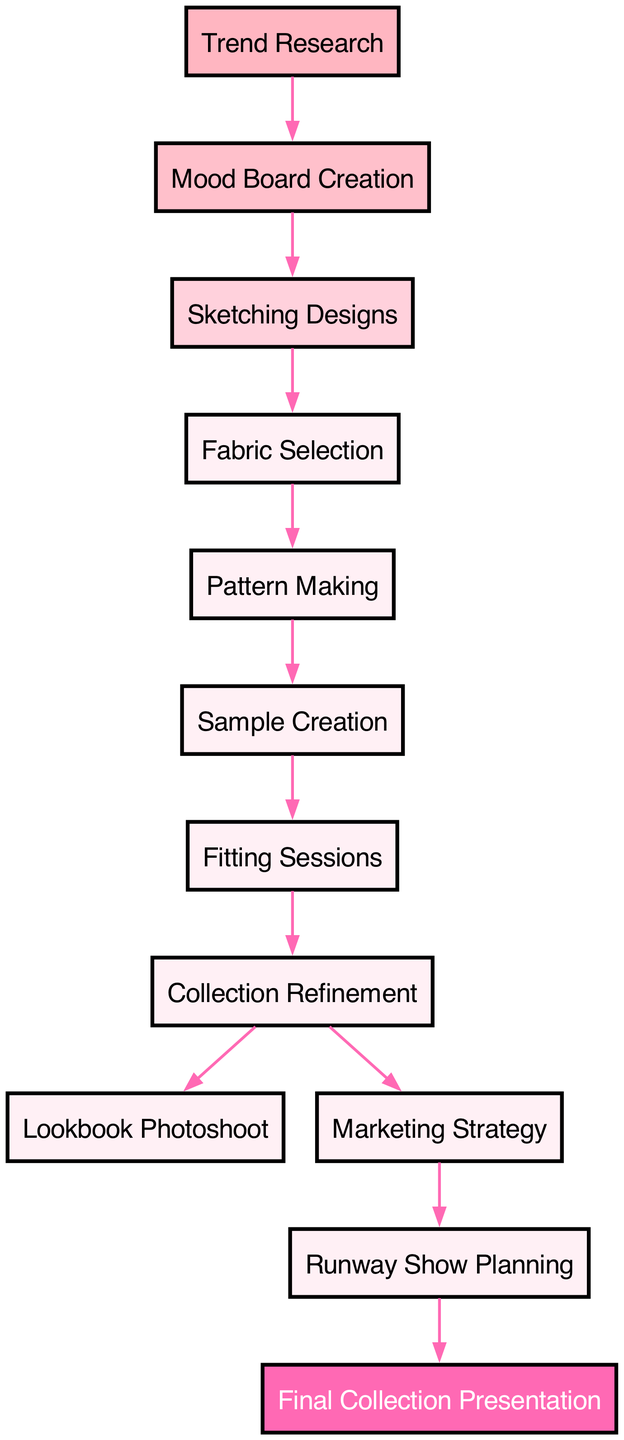What is the first step in the fashion collection development process? The diagram shows "Trend Research" as the starting point, which is the first node connected to the flow of the process.
Answer: Trend Research How many steps are there in total for the collection development process? The diagram lists 12 distinct nodes, indicating that there are 12 key steps involved in the process.
Answer: 12 What is the relationship between "Fabric Selection" and "Pattern Making"? The diagram illustrates a direct connection from "Fabric Selection" to "Pattern Making," indicating that pattern making follows after the selection of fabric.
Answer: Fabric Selection leads to Pattern Making After "Fitting Sessions," what is the next step in the process? From the flow of the diagram, "Fitting Sessions" leads directly into "Collection Refinement," showing that refinement is the subsequent step.
Answer: Collection Refinement Which node has the final collection presentation? The last node in the flow, "Final Collection Presentation," signifies that this is the concluding step of the process.
Answer: Final Collection Presentation What are the two branches that emanate from "Collection Refinement"? The diagram shows two edges leading out of "Collection Refinement": one going to "Lookbook Photoshoot" and the other to "Marketing Strategy," which illustrates the options that follow refinement.
Answer: Lookbook Photoshoot and Marketing Strategy How many edges are present in the diagram? By counting the connections (edges) between nodes in the diagram, there are a total of 11 edges that represent the flow between the various steps.
Answer: 11 What is the color of the "Final Collection Presentation" node? Referring to the styling in the diagram, "Final Collection Presentation" is uniquely colored with a pink shade, represented as '#FF69B4' in the styles.
Answer: Pink What is the node before "Lookbook Photoshoot"? The diagram clearly indicates a direct connection from "Collection Refinement" to "Lookbook Photoshoot," making collection refinement the predecessor step.
Answer: Collection Refinement 